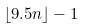<formula> <loc_0><loc_0><loc_500><loc_500>\lfloor 9 . 5 n \rfloor - 1</formula> 